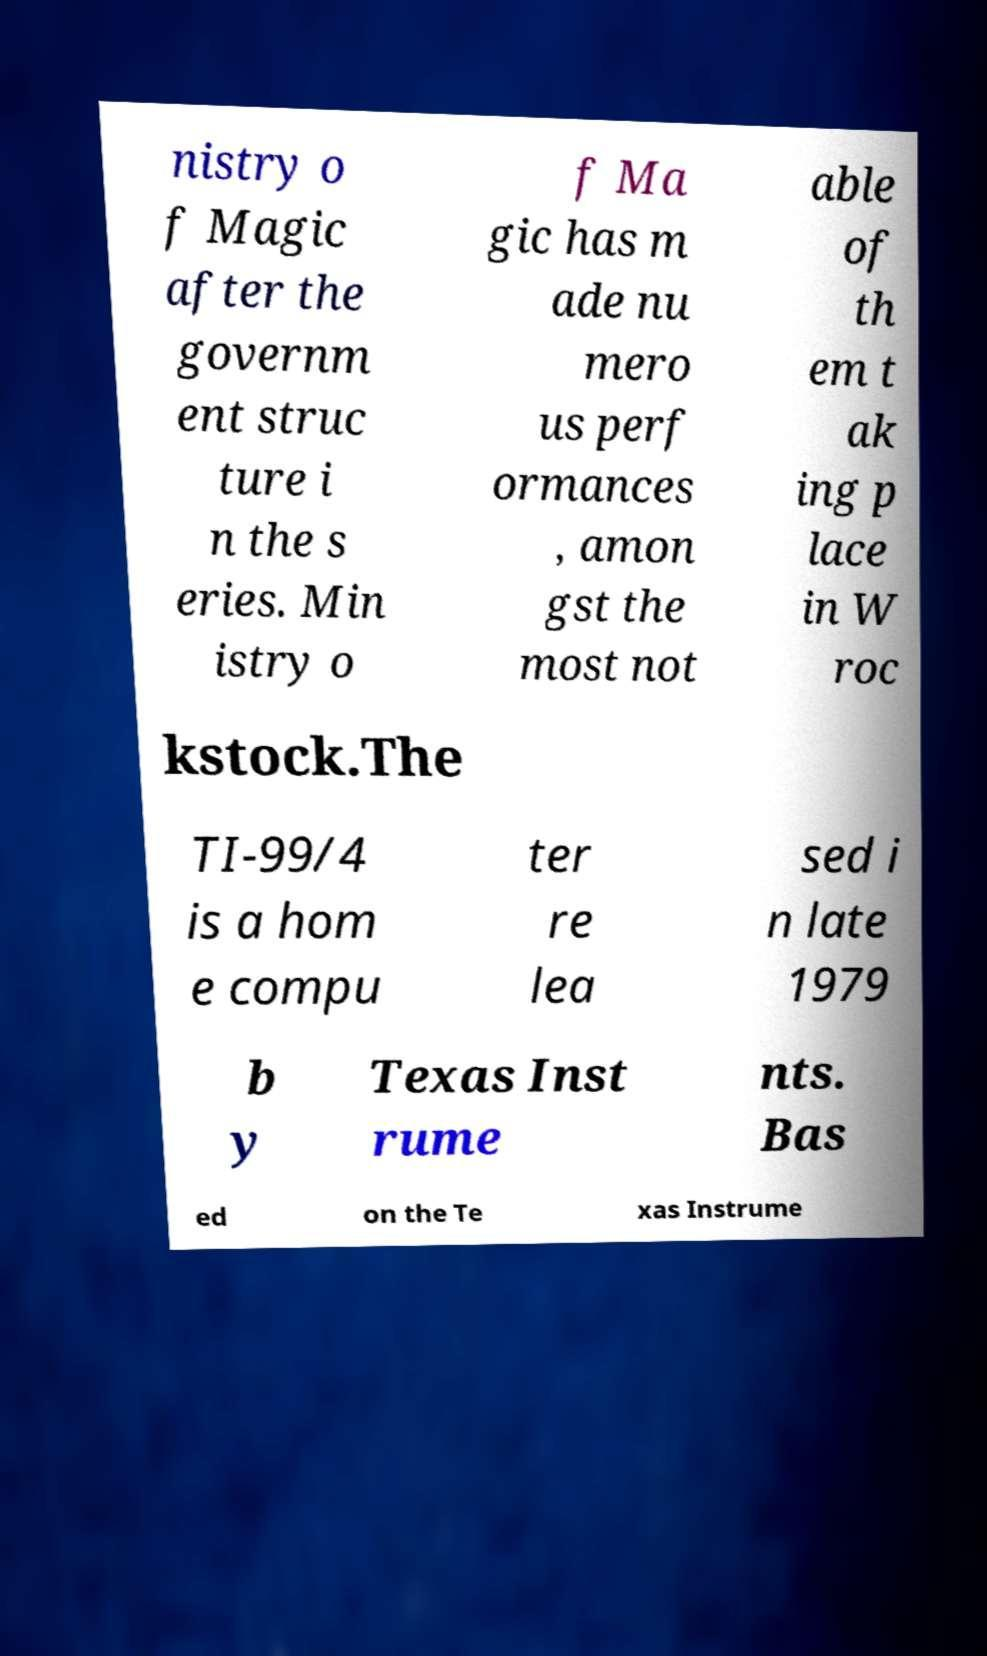What messages or text are displayed in this image? I need them in a readable, typed format. nistry o f Magic after the governm ent struc ture i n the s eries. Min istry o f Ma gic has m ade nu mero us perf ormances , amon gst the most not able of th em t ak ing p lace in W roc kstock.The TI-99/4 is a hom e compu ter re lea sed i n late 1979 b y Texas Inst rume nts. Bas ed on the Te xas Instrume 